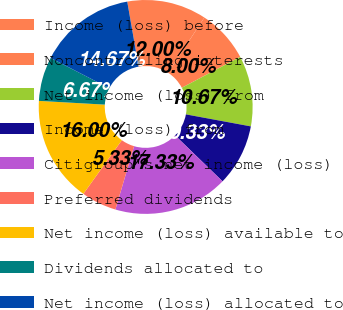<chart> <loc_0><loc_0><loc_500><loc_500><pie_chart><fcel>Income (loss) before<fcel>Noncontrolling interests<fcel>Net income (loss) from<fcel>Income (loss) from<fcel>Citigroup's net income (loss)<fcel>Preferred dividends<fcel>Net income (loss) available to<fcel>Dividends allocated to<fcel>Net income (loss) allocated to<nl><fcel>12.0%<fcel>8.0%<fcel>10.67%<fcel>9.33%<fcel>17.33%<fcel>5.33%<fcel>16.0%<fcel>6.67%<fcel>14.67%<nl></chart> 